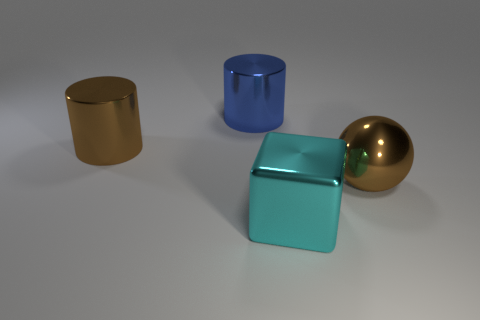Is there any other thing of the same color as the sphere?
Make the answer very short. Yes. What is the shape of the large blue object behind the object on the right side of the cyan metal thing?
Give a very brief answer. Cylinder. Are there more blue metal cylinders than cylinders?
Your answer should be very brief. No. What number of big shiny things are behind the shiny cube and in front of the blue object?
Your answer should be compact. 2. What number of big shiny things are in front of the brown thing that is right of the big cyan metallic object?
Offer a terse response. 1. How many things are either brown objects to the left of the large sphere or large blue metal things that are right of the big brown metallic cylinder?
Keep it short and to the point. 2. There is another big thing that is the same shape as the blue shiny thing; what is its material?
Offer a very short reply. Metal. What number of objects are objects that are in front of the brown metallic sphere or big cylinders?
Offer a very short reply. 3. There is a big cyan thing that is the same material as the blue cylinder; what shape is it?
Keep it short and to the point. Cube. How many other big blue metallic things have the same shape as the large blue metallic object?
Give a very brief answer. 0. 